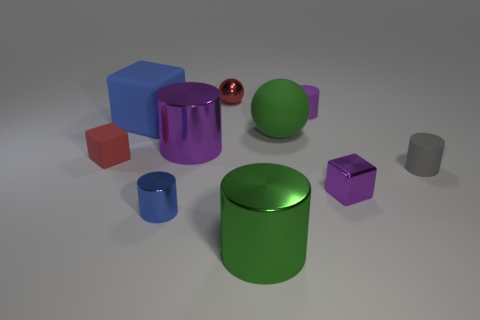Subtract all small metal blocks. How many blocks are left? 2 Subtract all red spheres. How many purple cylinders are left? 2 Subtract all purple cylinders. How many cylinders are left? 3 Subtract 1 blocks. How many blocks are left? 2 Subtract all blocks. How many objects are left? 7 Subtract all green cubes. Subtract all yellow cylinders. How many cubes are left? 3 Subtract 0 brown spheres. How many objects are left? 10 Subtract all large metal cylinders. Subtract all purple matte objects. How many objects are left? 7 Add 5 big metallic objects. How many big metallic objects are left? 7 Add 3 green things. How many green things exist? 5 